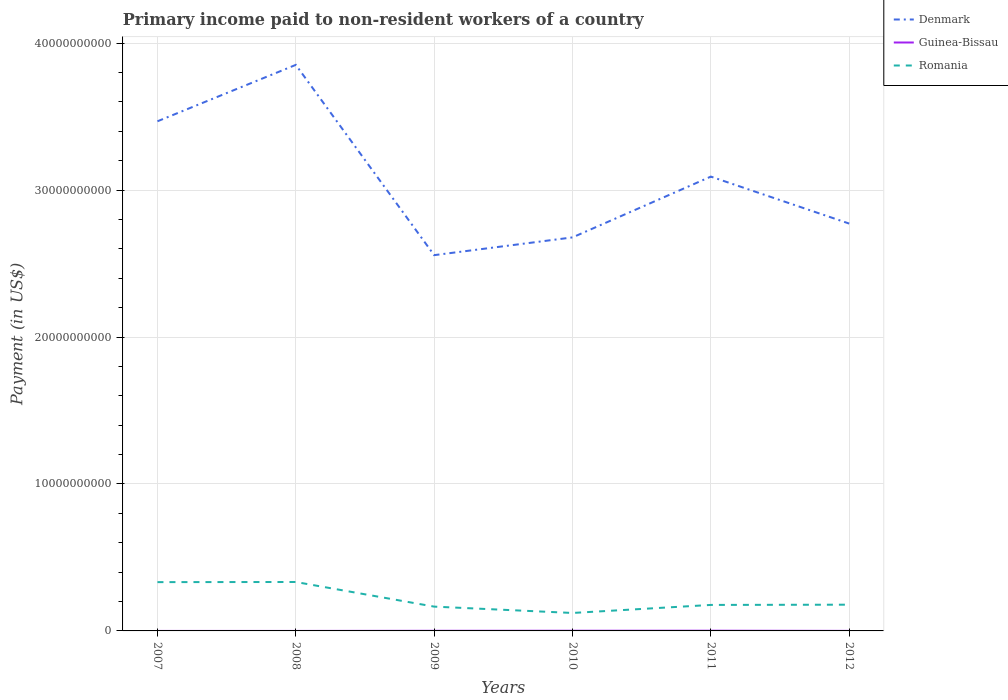How many different coloured lines are there?
Keep it short and to the point. 3. Does the line corresponding to Guinea-Bissau intersect with the line corresponding to Romania?
Your response must be concise. No. Is the number of lines equal to the number of legend labels?
Offer a terse response. Yes. Across all years, what is the maximum amount paid to workers in Guinea-Bissau?
Your answer should be compact. 1.80e+05. In which year was the amount paid to workers in Guinea-Bissau maximum?
Make the answer very short. 2008. What is the total amount paid to workers in Guinea-Bissau in the graph?
Your answer should be very brief. -8.46e+06. What is the difference between the highest and the second highest amount paid to workers in Romania?
Offer a very short reply. 2.11e+09. What is the difference between the highest and the lowest amount paid to workers in Guinea-Bissau?
Offer a terse response. 3. Is the amount paid to workers in Denmark strictly greater than the amount paid to workers in Romania over the years?
Make the answer very short. No. How many lines are there?
Your answer should be very brief. 3. Does the graph contain any zero values?
Provide a short and direct response. No. What is the title of the graph?
Your answer should be very brief. Primary income paid to non-resident workers of a country. Does "Malta" appear as one of the legend labels in the graph?
Your answer should be compact. No. What is the label or title of the Y-axis?
Offer a terse response. Payment (in US$). What is the Payment (in US$) of Denmark in 2007?
Your answer should be compact. 3.47e+1. What is the Payment (in US$) of Guinea-Bissau in 2007?
Keep it short and to the point. 4.40e+05. What is the Payment (in US$) in Romania in 2007?
Provide a short and direct response. 3.32e+09. What is the Payment (in US$) of Denmark in 2008?
Provide a short and direct response. 3.85e+1. What is the Payment (in US$) of Guinea-Bissau in 2008?
Your response must be concise. 1.80e+05. What is the Payment (in US$) in Romania in 2008?
Your answer should be compact. 3.33e+09. What is the Payment (in US$) in Denmark in 2009?
Offer a terse response. 2.56e+1. What is the Payment (in US$) of Guinea-Bissau in 2009?
Give a very brief answer. 8.64e+06. What is the Payment (in US$) of Romania in 2009?
Offer a very short reply. 1.65e+09. What is the Payment (in US$) of Denmark in 2010?
Provide a short and direct response. 2.68e+1. What is the Payment (in US$) of Guinea-Bissau in 2010?
Ensure brevity in your answer.  1.32e+07. What is the Payment (in US$) of Romania in 2010?
Offer a very short reply. 1.22e+09. What is the Payment (in US$) of Denmark in 2011?
Offer a terse response. 3.09e+1. What is the Payment (in US$) of Guinea-Bissau in 2011?
Offer a terse response. 1.53e+07. What is the Payment (in US$) of Romania in 2011?
Ensure brevity in your answer.  1.77e+09. What is the Payment (in US$) in Denmark in 2012?
Provide a short and direct response. 2.77e+1. What is the Payment (in US$) of Guinea-Bissau in 2012?
Keep it short and to the point. 3.23e+06. What is the Payment (in US$) in Romania in 2012?
Your response must be concise. 1.79e+09. Across all years, what is the maximum Payment (in US$) in Denmark?
Your answer should be very brief. 3.85e+1. Across all years, what is the maximum Payment (in US$) of Guinea-Bissau?
Provide a succinct answer. 1.53e+07. Across all years, what is the maximum Payment (in US$) of Romania?
Your answer should be compact. 3.33e+09. Across all years, what is the minimum Payment (in US$) of Denmark?
Make the answer very short. 2.56e+1. Across all years, what is the minimum Payment (in US$) of Guinea-Bissau?
Your answer should be very brief. 1.80e+05. Across all years, what is the minimum Payment (in US$) of Romania?
Give a very brief answer. 1.22e+09. What is the total Payment (in US$) in Denmark in the graph?
Offer a very short reply. 1.84e+11. What is the total Payment (in US$) of Guinea-Bissau in the graph?
Your answer should be compact. 4.09e+07. What is the total Payment (in US$) in Romania in the graph?
Your answer should be compact. 1.31e+1. What is the difference between the Payment (in US$) in Denmark in 2007 and that in 2008?
Offer a very short reply. -3.84e+09. What is the difference between the Payment (in US$) of Guinea-Bissau in 2007 and that in 2008?
Give a very brief answer. 2.60e+05. What is the difference between the Payment (in US$) of Romania in 2007 and that in 2008?
Offer a terse response. -9.00e+06. What is the difference between the Payment (in US$) in Denmark in 2007 and that in 2009?
Offer a very short reply. 9.11e+09. What is the difference between the Payment (in US$) in Guinea-Bissau in 2007 and that in 2009?
Give a very brief answer. -8.20e+06. What is the difference between the Payment (in US$) of Romania in 2007 and that in 2009?
Ensure brevity in your answer.  1.67e+09. What is the difference between the Payment (in US$) in Denmark in 2007 and that in 2010?
Offer a very short reply. 7.90e+09. What is the difference between the Payment (in US$) of Guinea-Bissau in 2007 and that in 2010?
Your response must be concise. -1.28e+07. What is the difference between the Payment (in US$) in Romania in 2007 and that in 2010?
Keep it short and to the point. 2.10e+09. What is the difference between the Payment (in US$) of Denmark in 2007 and that in 2011?
Provide a succinct answer. 3.76e+09. What is the difference between the Payment (in US$) in Guinea-Bissau in 2007 and that in 2011?
Ensure brevity in your answer.  -1.48e+07. What is the difference between the Payment (in US$) in Romania in 2007 and that in 2011?
Offer a terse response. 1.55e+09. What is the difference between the Payment (in US$) in Denmark in 2007 and that in 2012?
Keep it short and to the point. 6.96e+09. What is the difference between the Payment (in US$) of Guinea-Bissau in 2007 and that in 2012?
Keep it short and to the point. -2.79e+06. What is the difference between the Payment (in US$) of Romania in 2007 and that in 2012?
Make the answer very short. 1.54e+09. What is the difference between the Payment (in US$) in Denmark in 2008 and that in 2009?
Your answer should be very brief. 1.29e+1. What is the difference between the Payment (in US$) of Guinea-Bissau in 2008 and that in 2009?
Your answer should be very brief. -8.46e+06. What is the difference between the Payment (in US$) in Romania in 2008 and that in 2009?
Your response must be concise. 1.68e+09. What is the difference between the Payment (in US$) of Denmark in 2008 and that in 2010?
Your response must be concise. 1.17e+1. What is the difference between the Payment (in US$) of Guinea-Bissau in 2008 and that in 2010?
Your answer should be compact. -1.30e+07. What is the difference between the Payment (in US$) in Romania in 2008 and that in 2010?
Provide a short and direct response. 2.11e+09. What is the difference between the Payment (in US$) of Denmark in 2008 and that in 2011?
Keep it short and to the point. 7.60e+09. What is the difference between the Payment (in US$) of Guinea-Bissau in 2008 and that in 2011?
Your answer should be very brief. -1.51e+07. What is the difference between the Payment (in US$) in Romania in 2008 and that in 2011?
Keep it short and to the point. 1.56e+09. What is the difference between the Payment (in US$) in Denmark in 2008 and that in 2012?
Your answer should be very brief. 1.08e+1. What is the difference between the Payment (in US$) in Guinea-Bissau in 2008 and that in 2012?
Give a very brief answer. -3.05e+06. What is the difference between the Payment (in US$) in Romania in 2008 and that in 2012?
Your response must be concise. 1.54e+09. What is the difference between the Payment (in US$) of Denmark in 2009 and that in 2010?
Your response must be concise. -1.21e+09. What is the difference between the Payment (in US$) in Guinea-Bissau in 2009 and that in 2010?
Your response must be concise. -4.56e+06. What is the difference between the Payment (in US$) in Romania in 2009 and that in 2010?
Your answer should be compact. 4.32e+08. What is the difference between the Payment (in US$) of Denmark in 2009 and that in 2011?
Your response must be concise. -5.35e+09. What is the difference between the Payment (in US$) of Guinea-Bissau in 2009 and that in 2011?
Your answer should be compact. -6.62e+06. What is the difference between the Payment (in US$) in Romania in 2009 and that in 2011?
Your answer should be very brief. -1.15e+08. What is the difference between the Payment (in US$) of Denmark in 2009 and that in 2012?
Offer a very short reply. -2.15e+09. What is the difference between the Payment (in US$) of Guinea-Bissau in 2009 and that in 2012?
Provide a succinct answer. 5.41e+06. What is the difference between the Payment (in US$) of Romania in 2009 and that in 2012?
Provide a succinct answer. -1.32e+08. What is the difference between the Payment (in US$) in Denmark in 2010 and that in 2011?
Ensure brevity in your answer.  -4.14e+09. What is the difference between the Payment (in US$) of Guinea-Bissau in 2010 and that in 2011?
Provide a short and direct response. -2.06e+06. What is the difference between the Payment (in US$) in Romania in 2010 and that in 2011?
Make the answer very short. -5.47e+08. What is the difference between the Payment (in US$) of Denmark in 2010 and that in 2012?
Make the answer very short. -9.41e+08. What is the difference between the Payment (in US$) of Guinea-Bissau in 2010 and that in 2012?
Your answer should be compact. 9.97e+06. What is the difference between the Payment (in US$) in Romania in 2010 and that in 2012?
Offer a terse response. -5.64e+08. What is the difference between the Payment (in US$) in Denmark in 2011 and that in 2012?
Your answer should be compact. 3.20e+09. What is the difference between the Payment (in US$) of Guinea-Bissau in 2011 and that in 2012?
Offer a terse response. 1.20e+07. What is the difference between the Payment (in US$) of Romania in 2011 and that in 2012?
Offer a terse response. -1.70e+07. What is the difference between the Payment (in US$) in Denmark in 2007 and the Payment (in US$) in Guinea-Bissau in 2008?
Keep it short and to the point. 3.47e+1. What is the difference between the Payment (in US$) in Denmark in 2007 and the Payment (in US$) in Romania in 2008?
Keep it short and to the point. 3.14e+1. What is the difference between the Payment (in US$) in Guinea-Bissau in 2007 and the Payment (in US$) in Romania in 2008?
Give a very brief answer. -3.33e+09. What is the difference between the Payment (in US$) of Denmark in 2007 and the Payment (in US$) of Guinea-Bissau in 2009?
Provide a short and direct response. 3.47e+1. What is the difference between the Payment (in US$) in Denmark in 2007 and the Payment (in US$) in Romania in 2009?
Provide a succinct answer. 3.30e+1. What is the difference between the Payment (in US$) of Guinea-Bissau in 2007 and the Payment (in US$) of Romania in 2009?
Give a very brief answer. -1.65e+09. What is the difference between the Payment (in US$) of Denmark in 2007 and the Payment (in US$) of Guinea-Bissau in 2010?
Provide a succinct answer. 3.47e+1. What is the difference between the Payment (in US$) of Denmark in 2007 and the Payment (in US$) of Romania in 2010?
Offer a very short reply. 3.35e+1. What is the difference between the Payment (in US$) in Guinea-Bissau in 2007 and the Payment (in US$) in Romania in 2010?
Offer a very short reply. -1.22e+09. What is the difference between the Payment (in US$) of Denmark in 2007 and the Payment (in US$) of Guinea-Bissau in 2011?
Keep it short and to the point. 3.47e+1. What is the difference between the Payment (in US$) in Denmark in 2007 and the Payment (in US$) in Romania in 2011?
Provide a succinct answer. 3.29e+1. What is the difference between the Payment (in US$) of Guinea-Bissau in 2007 and the Payment (in US$) of Romania in 2011?
Keep it short and to the point. -1.77e+09. What is the difference between the Payment (in US$) in Denmark in 2007 and the Payment (in US$) in Guinea-Bissau in 2012?
Your answer should be compact. 3.47e+1. What is the difference between the Payment (in US$) in Denmark in 2007 and the Payment (in US$) in Romania in 2012?
Offer a terse response. 3.29e+1. What is the difference between the Payment (in US$) in Guinea-Bissau in 2007 and the Payment (in US$) in Romania in 2012?
Your answer should be very brief. -1.79e+09. What is the difference between the Payment (in US$) in Denmark in 2008 and the Payment (in US$) in Guinea-Bissau in 2009?
Keep it short and to the point. 3.85e+1. What is the difference between the Payment (in US$) in Denmark in 2008 and the Payment (in US$) in Romania in 2009?
Your response must be concise. 3.69e+1. What is the difference between the Payment (in US$) of Guinea-Bissau in 2008 and the Payment (in US$) of Romania in 2009?
Keep it short and to the point. -1.65e+09. What is the difference between the Payment (in US$) in Denmark in 2008 and the Payment (in US$) in Guinea-Bissau in 2010?
Provide a succinct answer. 3.85e+1. What is the difference between the Payment (in US$) in Denmark in 2008 and the Payment (in US$) in Romania in 2010?
Give a very brief answer. 3.73e+1. What is the difference between the Payment (in US$) of Guinea-Bissau in 2008 and the Payment (in US$) of Romania in 2010?
Offer a very short reply. -1.22e+09. What is the difference between the Payment (in US$) in Denmark in 2008 and the Payment (in US$) in Guinea-Bissau in 2011?
Your answer should be compact. 3.85e+1. What is the difference between the Payment (in US$) of Denmark in 2008 and the Payment (in US$) of Romania in 2011?
Provide a short and direct response. 3.68e+1. What is the difference between the Payment (in US$) of Guinea-Bissau in 2008 and the Payment (in US$) of Romania in 2011?
Your answer should be compact. -1.77e+09. What is the difference between the Payment (in US$) of Denmark in 2008 and the Payment (in US$) of Guinea-Bissau in 2012?
Provide a succinct answer. 3.85e+1. What is the difference between the Payment (in US$) of Denmark in 2008 and the Payment (in US$) of Romania in 2012?
Give a very brief answer. 3.67e+1. What is the difference between the Payment (in US$) in Guinea-Bissau in 2008 and the Payment (in US$) in Romania in 2012?
Your response must be concise. -1.79e+09. What is the difference between the Payment (in US$) in Denmark in 2009 and the Payment (in US$) in Guinea-Bissau in 2010?
Make the answer very short. 2.56e+1. What is the difference between the Payment (in US$) in Denmark in 2009 and the Payment (in US$) in Romania in 2010?
Your response must be concise. 2.44e+1. What is the difference between the Payment (in US$) in Guinea-Bissau in 2009 and the Payment (in US$) in Romania in 2010?
Provide a short and direct response. -1.21e+09. What is the difference between the Payment (in US$) of Denmark in 2009 and the Payment (in US$) of Guinea-Bissau in 2011?
Give a very brief answer. 2.56e+1. What is the difference between the Payment (in US$) of Denmark in 2009 and the Payment (in US$) of Romania in 2011?
Keep it short and to the point. 2.38e+1. What is the difference between the Payment (in US$) of Guinea-Bissau in 2009 and the Payment (in US$) of Romania in 2011?
Ensure brevity in your answer.  -1.76e+09. What is the difference between the Payment (in US$) of Denmark in 2009 and the Payment (in US$) of Guinea-Bissau in 2012?
Offer a terse response. 2.56e+1. What is the difference between the Payment (in US$) in Denmark in 2009 and the Payment (in US$) in Romania in 2012?
Provide a short and direct response. 2.38e+1. What is the difference between the Payment (in US$) in Guinea-Bissau in 2009 and the Payment (in US$) in Romania in 2012?
Offer a terse response. -1.78e+09. What is the difference between the Payment (in US$) of Denmark in 2010 and the Payment (in US$) of Guinea-Bissau in 2011?
Keep it short and to the point. 2.68e+1. What is the difference between the Payment (in US$) in Denmark in 2010 and the Payment (in US$) in Romania in 2011?
Provide a short and direct response. 2.50e+1. What is the difference between the Payment (in US$) of Guinea-Bissau in 2010 and the Payment (in US$) of Romania in 2011?
Your answer should be very brief. -1.76e+09. What is the difference between the Payment (in US$) in Denmark in 2010 and the Payment (in US$) in Guinea-Bissau in 2012?
Ensure brevity in your answer.  2.68e+1. What is the difference between the Payment (in US$) in Denmark in 2010 and the Payment (in US$) in Romania in 2012?
Provide a succinct answer. 2.50e+1. What is the difference between the Payment (in US$) in Guinea-Bissau in 2010 and the Payment (in US$) in Romania in 2012?
Ensure brevity in your answer.  -1.77e+09. What is the difference between the Payment (in US$) of Denmark in 2011 and the Payment (in US$) of Guinea-Bissau in 2012?
Offer a very short reply. 3.09e+1. What is the difference between the Payment (in US$) of Denmark in 2011 and the Payment (in US$) of Romania in 2012?
Your response must be concise. 2.91e+1. What is the difference between the Payment (in US$) in Guinea-Bissau in 2011 and the Payment (in US$) in Romania in 2012?
Keep it short and to the point. -1.77e+09. What is the average Payment (in US$) of Denmark per year?
Your answer should be compact. 3.07e+1. What is the average Payment (in US$) of Guinea-Bissau per year?
Give a very brief answer. 6.82e+06. What is the average Payment (in US$) of Romania per year?
Provide a short and direct response. 2.18e+09. In the year 2007, what is the difference between the Payment (in US$) in Denmark and Payment (in US$) in Guinea-Bissau?
Give a very brief answer. 3.47e+1. In the year 2007, what is the difference between the Payment (in US$) of Denmark and Payment (in US$) of Romania?
Your response must be concise. 3.14e+1. In the year 2007, what is the difference between the Payment (in US$) in Guinea-Bissau and Payment (in US$) in Romania?
Keep it short and to the point. -3.32e+09. In the year 2008, what is the difference between the Payment (in US$) in Denmark and Payment (in US$) in Guinea-Bissau?
Your response must be concise. 3.85e+1. In the year 2008, what is the difference between the Payment (in US$) of Denmark and Payment (in US$) of Romania?
Offer a terse response. 3.52e+1. In the year 2008, what is the difference between the Payment (in US$) of Guinea-Bissau and Payment (in US$) of Romania?
Your response must be concise. -3.33e+09. In the year 2009, what is the difference between the Payment (in US$) of Denmark and Payment (in US$) of Guinea-Bissau?
Your response must be concise. 2.56e+1. In the year 2009, what is the difference between the Payment (in US$) in Denmark and Payment (in US$) in Romania?
Offer a very short reply. 2.39e+1. In the year 2009, what is the difference between the Payment (in US$) in Guinea-Bissau and Payment (in US$) in Romania?
Keep it short and to the point. -1.65e+09. In the year 2010, what is the difference between the Payment (in US$) in Denmark and Payment (in US$) in Guinea-Bissau?
Keep it short and to the point. 2.68e+1. In the year 2010, what is the difference between the Payment (in US$) in Denmark and Payment (in US$) in Romania?
Provide a succinct answer. 2.56e+1. In the year 2010, what is the difference between the Payment (in US$) in Guinea-Bissau and Payment (in US$) in Romania?
Your response must be concise. -1.21e+09. In the year 2011, what is the difference between the Payment (in US$) of Denmark and Payment (in US$) of Guinea-Bissau?
Ensure brevity in your answer.  3.09e+1. In the year 2011, what is the difference between the Payment (in US$) in Denmark and Payment (in US$) in Romania?
Make the answer very short. 2.91e+1. In the year 2011, what is the difference between the Payment (in US$) in Guinea-Bissau and Payment (in US$) in Romania?
Offer a very short reply. -1.75e+09. In the year 2012, what is the difference between the Payment (in US$) in Denmark and Payment (in US$) in Guinea-Bissau?
Provide a succinct answer. 2.77e+1. In the year 2012, what is the difference between the Payment (in US$) of Denmark and Payment (in US$) of Romania?
Make the answer very short. 2.59e+1. In the year 2012, what is the difference between the Payment (in US$) of Guinea-Bissau and Payment (in US$) of Romania?
Provide a succinct answer. -1.78e+09. What is the ratio of the Payment (in US$) of Denmark in 2007 to that in 2008?
Keep it short and to the point. 0.9. What is the ratio of the Payment (in US$) in Guinea-Bissau in 2007 to that in 2008?
Make the answer very short. 2.44. What is the ratio of the Payment (in US$) of Romania in 2007 to that in 2008?
Keep it short and to the point. 1. What is the ratio of the Payment (in US$) in Denmark in 2007 to that in 2009?
Ensure brevity in your answer.  1.36. What is the ratio of the Payment (in US$) of Guinea-Bissau in 2007 to that in 2009?
Your answer should be very brief. 0.05. What is the ratio of the Payment (in US$) of Romania in 2007 to that in 2009?
Give a very brief answer. 2.01. What is the ratio of the Payment (in US$) in Denmark in 2007 to that in 2010?
Your response must be concise. 1.29. What is the ratio of the Payment (in US$) in Romania in 2007 to that in 2010?
Keep it short and to the point. 2.72. What is the ratio of the Payment (in US$) of Denmark in 2007 to that in 2011?
Offer a very short reply. 1.12. What is the ratio of the Payment (in US$) in Guinea-Bissau in 2007 to that in 2011?
Ensure brevity in your answer.  0.03. What is the ratio of the Payment (in US$) in Romania in 2007 to that in 2011?
Provide a succinct answer. 1.88. What is the ratio of the Payment (in US$) of Denmark in 2007 to that in 2012?
Your answer should be compact. 1.25. What is the ratio of the Payment (in US$) of Guinea-Bissau in 2007 to that in 2012?
Your answer should be very brief. 0.14. What is the ratio of the Payment (in US$) in Romania in 2007 to that in 2012?
Ensure brevity in your answer.  1.86. What is the ratio of the Payment (in US$) in Denmark in 2008 to that in 2009?
Offer a terse response. 1.51. What is the ratio of the Payment (in US$) in Guinea-Bissau in 2008 to that in 2009?
Ensure brevity in your answer.  0.02. What is the ratio of the Payment (in US$) of Romania in 2008 to that in 2009?
Keep it short and to the point. 2.01. What is the ratio of the Payment (in US$) in Denmark in 2008 to that in 2010?
Your answer should be very brief. 1.44. What is the ratio of the Payment (in US$) in Guinea-Bissau in 2008 to that in 2010?
Provide a short and direct response. 0.01. What is the ratio of the Payment (in US$) of Romania in 2008 to that in 2010?
Your answer should be very brief. 2.73. What is the ratio of the Payment (in US$) in Denmark in 2008 to that in 2011?
Your answer should be very brief. 1.25. What is the ratio of the Payment (in US$) of Guinea-Bissau in 2008 to that in 2011?
Your answer should be compact. 0.01. What is the ratio of the Payment (in US$) of Romania in 2008 to that in 2011?
Your answer should be very brief. 1.88. What is the ratio of the Payment (in US$) in Denmark in 2008 to that in 2012?
Provide a succinct answer. 1.39. What is the ratio of the Payment (in US$) of Guinea-Bissau in 2008 to that in 2012?
Keep it short and to the point. 0.06. What is the ratio of the Payment (in US$) of Romania in 2008 to that in 2012?
Make the answer very short. 1.86. What is the ratio of the Payment (in US$) in Denmark in 2009 to that in 2010?
Offer a very short reply. 0.95. What is the ratio of the Payment (in US$) in Guinea-Bissau in 2009 to that in 2010?
Give a very brief answer. 0.65. What is the ratio of the Payment (in US$) in Romania in 2009 to that in 2010?
Make the answer very short. 1.35. What is the ratio of the Payment (in US$) in Denmark in 2009 to that in 2011?
Your answer should be compact. 0.83. What is the ratio of the Payment (in US$) of Guinea-Bissau in 2009 to that in 2011?
Ensure brevity in your answer.  0.57. What is the ratio of the Payment (in US$) of Romania in 2009 to that in 2011?
Your response must be concise. 0.94. What is the ratio of the Payment (in US$) in Denmark in 2009 to that in 2012?
Provide a succinct answer. 0.92. What is the ratio of the Payment (in US$) in Guinea-Bissau in 2009 to that in 2012?
Provide a short and direct response. 2.68. What is the ratio of the Payment (in US$) of Romania in 2009 to that in 2012?
Ensure brevity in your answer.  0.93. What is the ratio of the Payment (in US$) in Denmark in 2010 to that in 2011?
Offer a terse response. 0.87. What is the ratio of the Payment (in US$) in Guinea-Bissau in 2010 to that in 2011?
Provide a short and direct response. 0.86. What is the ratio of the Payment (in US$) in Romania in 2010 to that in 2011?
Provide a succinct answer. 0.69. What is the ratio of the Payment (in US$) in Denmark in 2010 to that in 2012?
Provide a succinct answer. 0.97. What is the ratio of the Payment (in US$) of Guinea-Bissau in 2010 to that in 2012?
Your answer should be very brief. 4.09. What is the ratio of the Payment (in US$) in Romania in 2010 to that in 2012?
Your response must be concise. 0.68. What is the ratio of the Payment (in US$) in Denmark in 2011 to that in 2012?
Your response must be concise. 1.12. What is the ratio of the Payment (in US$) in Guinea-Bissau in 2011 to that in 2012?
Give a very brief answer. 4.73. What is the ratio of the Payment (in US$) of Romania in 2011 to that in 2012?
Keep it short and to the point. 0.99. What is the difference between the highest and the second highest Payment (in US$) in Denmark?
Ensure brevity in your answer.  3.84e+09. What is the difference between the highest and the second highest Payment (in US$) in Guinea-Bissau?
Provide a succinct answer. 2.06e+06. What is the difference between the highest and the second highest Payment (in US$) of Romania?
Offer a very short reply. 9.00e+06. What is the difference between the highest and the lowest Payment (in US$) in Denmark?
Make the answer very short. 1.29e+1. What is the difference between the highest and the lowest Payment (in US$) of Guinea-Bissau?
Give a very brief answer. 1.51e+07. What is the difference between the highest and the lowest Payment (in US$) in Romania?
Give a very brief answer. 2.11e+09. 